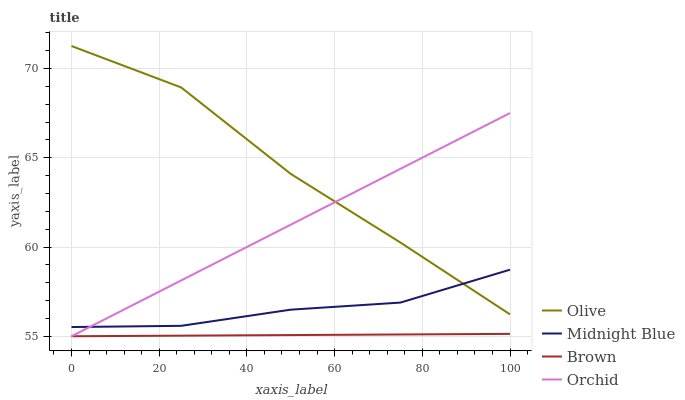Does Brown have the minimum area under the curve?
Answer yes or no. Yes. Does Olive have the maximum area under the curve?
Answer yes or no. Yes. Does Midnight Blue have the minimum area under the curve?
Answer yes or no. No. Does Midnight Blue have the maximum area under the curve?
Answer yes or no. No. Is Brown the smoothest?
Answer yes or no. Yes. Is Olive the roughest?
Answer yes or no. Yes. Is Midnight Blue the smoothest?
Answer yes or no. No. Is Midnight Blue the roughest?
Answer yes or no. No. Does Midnight Blue have the lowest value?
Answer yes or no. No. Does Olive have the highest value?
Answer yes or no. Yes. Does Midnight Blue have the highest value?
Answer yes or no. No. Is Brown less than Olive?
Answer yes or no. Yes. Is Midnight Blue greater than Brown?
Answer yes or no. Yes. Does Orchid intersect Olive?
Answer yes or no. Yes. Is Orchid less than Olive?
Answer yes or no. No. Is Orchid greater than Olive?
Answer yes or no. No. Does Brown intersect Olive?
Answer yes or no. No. 